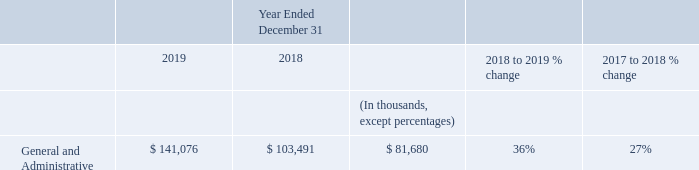General and Administrative Expenses
General and administrative expenses increased $38 million, or 36%, in 2019 compared to 2018. The overall increase was primarily due to increased employee compensation-related costs of $15 million, driven by headcount growth, and a one-time termination-related charge of $3 million during 2019. The overall increase was also driven by costs associated with our acquisition of Smooch in 2019 including transaction costs of $3 million and a one-time share-based compensation charge of $3 million related to accelerated stock options of Smooch. Further contributing to the overall increase was an increase in allocated shared costs of $3 million
General and administrative expenses increased $22 million, or 27%, in 2018 compared to 2017. The overall increase was primarily due to increased employee compensation-related costs of $15 million, driven by headcount growth, and increased allocated shared costs of $3 million.
What is the percentage increase in General and Administrative expenses from 2018 to 2019 36%. What was the increase in general and administrative expenses from 2017 to 2018?
Answer scale should be: million. 22. What is the difference between the increase in general and administrative expenses from 2018 to 2019 and 2017 to 2018?
Answer scale should be: million. 38 - 22 
Answer: 16. What are the components of the costs associated with acquisition of Smooch in 2019? The overall increase was also driven by costs associated with our acquisition of smooch in 2019 including transaction costs of $3 million and a one-time share-based compensation charge of $3 million related to accelerated stock options of smooch. What is the increase in percentage of general and administrative expenses from 2017 to 2019?
Answer scale should be: percent. (141,076 - 81,680)/81,680 
Answer: 72.72. What is the overall increase in general and administrative expenses from 2017 to 2019?
Answer scale should be: million. 38 + 22 
Answer: 60. 